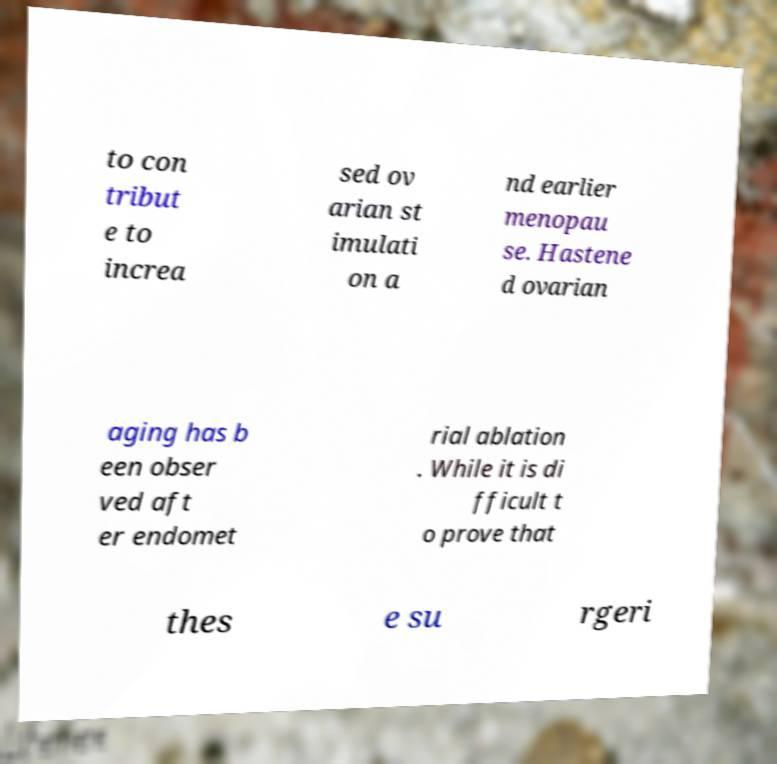For documentation purposes, I need the text within this image transcribed. Could you provide that? to con tribut e to increa sed ov arian st imulati on a nd earlier menopau se. Hastene d ovarian aging has b een obser ved aft er endomet rial ablation . While it is di fficult t o prove that thes e su rgeri 